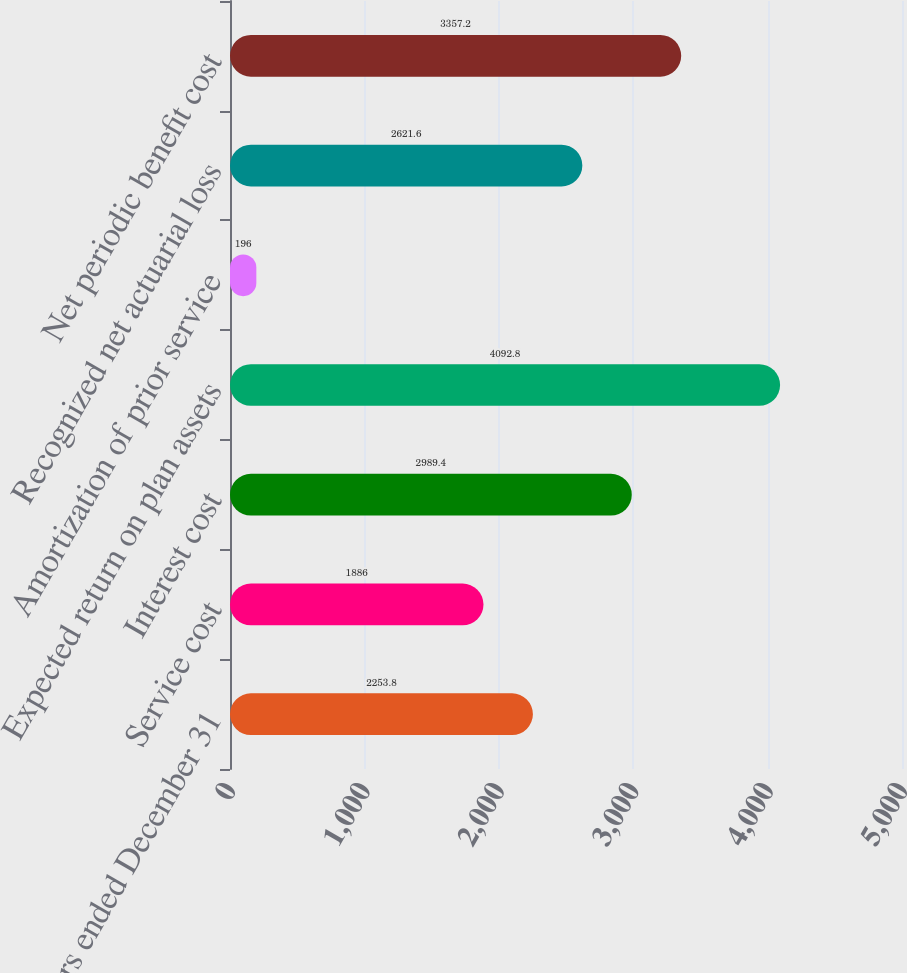Convert chart. <chart><loc_0><loc_0><loc_500><loc_500><bar_chart><fcel>Years ended December 31<fcel>Service cost<fcel>Interest cost<fcel>Expected return on plan assets<fcel>Amortization of prior service<fcel>Recognized net actuarial loss<fcel>Net periodic benefit cost<nl><fcel>2253.8<fcel>1886<fcel>2989.4<fcel>4092.8<fcel>196<fcel>2621.6<fcel>3357.2<nl></chart> 